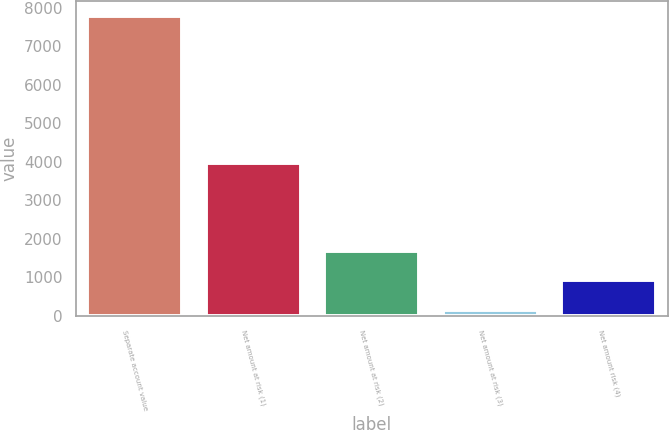Convert chart. <chart><loc_0><loc_0><loc_500><loc_500><bar_chart><fcel>Separate account value<fcel>Net amount at risk (1)<fcel>Net amount at risk (2)<fcel>Net amount at risk (3)<fcel>Net amount risk (4)<nl><fcel>7802<fcel>3971<fcel>1687.6<fcel>159<fcel>923.3<nl></chart> 